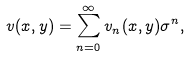<formula> <loc_0><loc_0><loc_500><loc_500>v ( x , y ) = \sum _ { n = 0 } ^ { \infty } v _ { n } ( x , y ) \sigma ^ { n } ,</formula> 